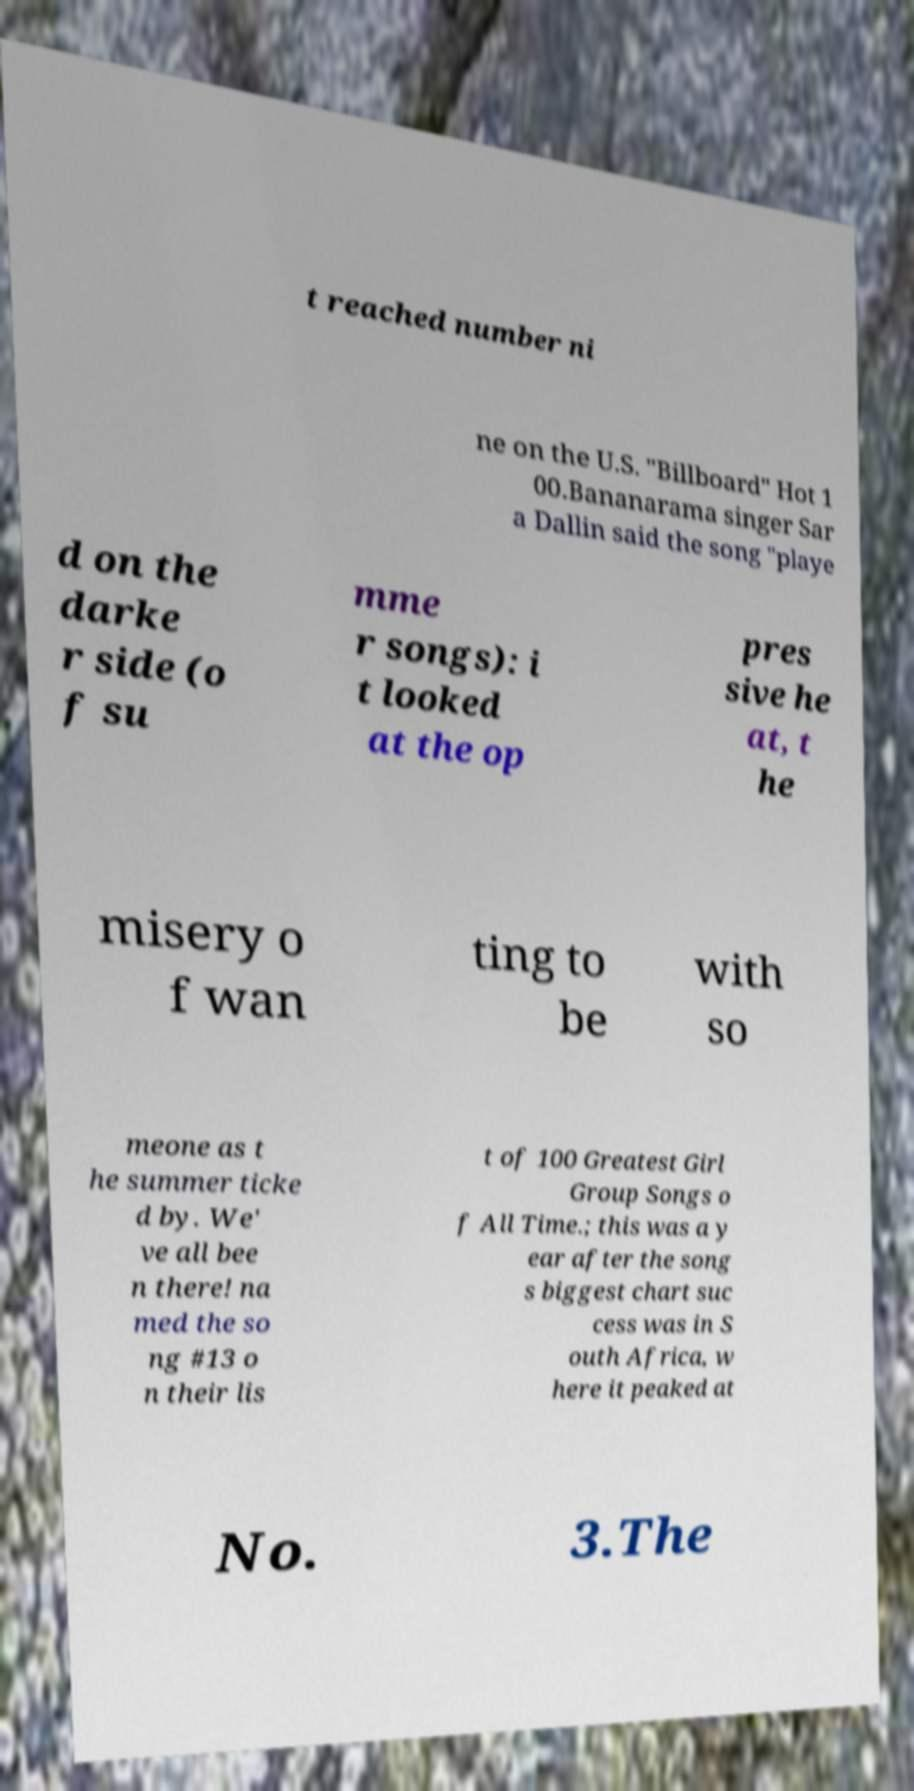Could you assist in decoding the text presented in this image and type it out clearly? t reached number ni ne on the U.S. "Billboard" Hot 1 00.Bananarama singer Sar a Dallin said the song "playe d on the darke r side (o f su mme r songs): i t looked at the op pres sive he at, t he misery o f wan ting to be with so meone as t he summer ticke d by. We' ve all bee n there! na med the so ng #13 o n their lis t of 100 Greatest Girl Group Songs o f All Time.; this was a y ear after the song s biggest chart suc cess was in S outh Africa, w here it peaked at No. 3.The 